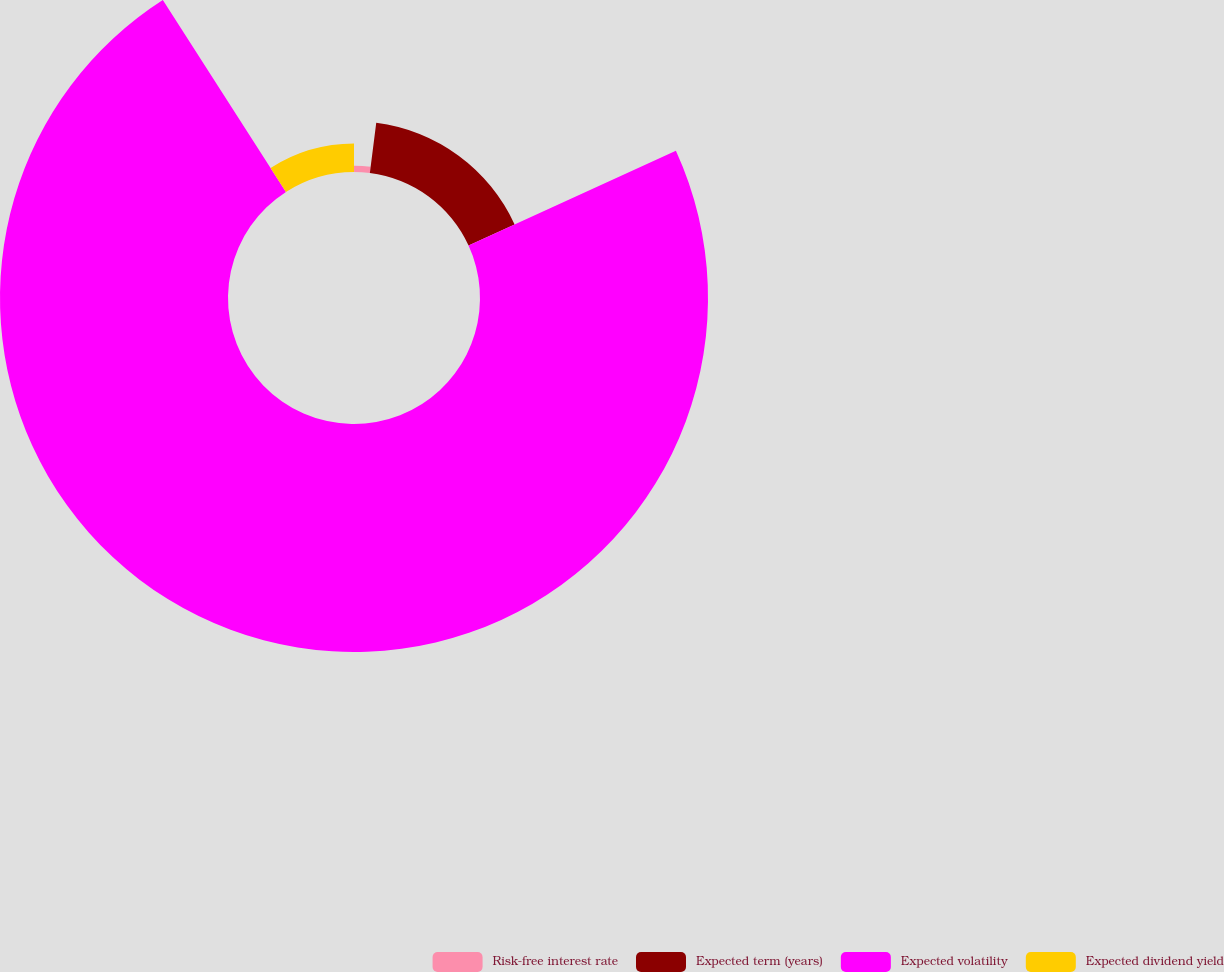<chart> <loc_0><loc_0><loc_500><loc_500><pie_chart><fcel>Risk-free interest rate<fcel>Expected term (years)<fcel>Expected volatility<fcel>Expected dividend yield<nl><fcel>2.01%<fcel>16.16%<fcel>72.75%<fcel>9.08%<nl></chart> 